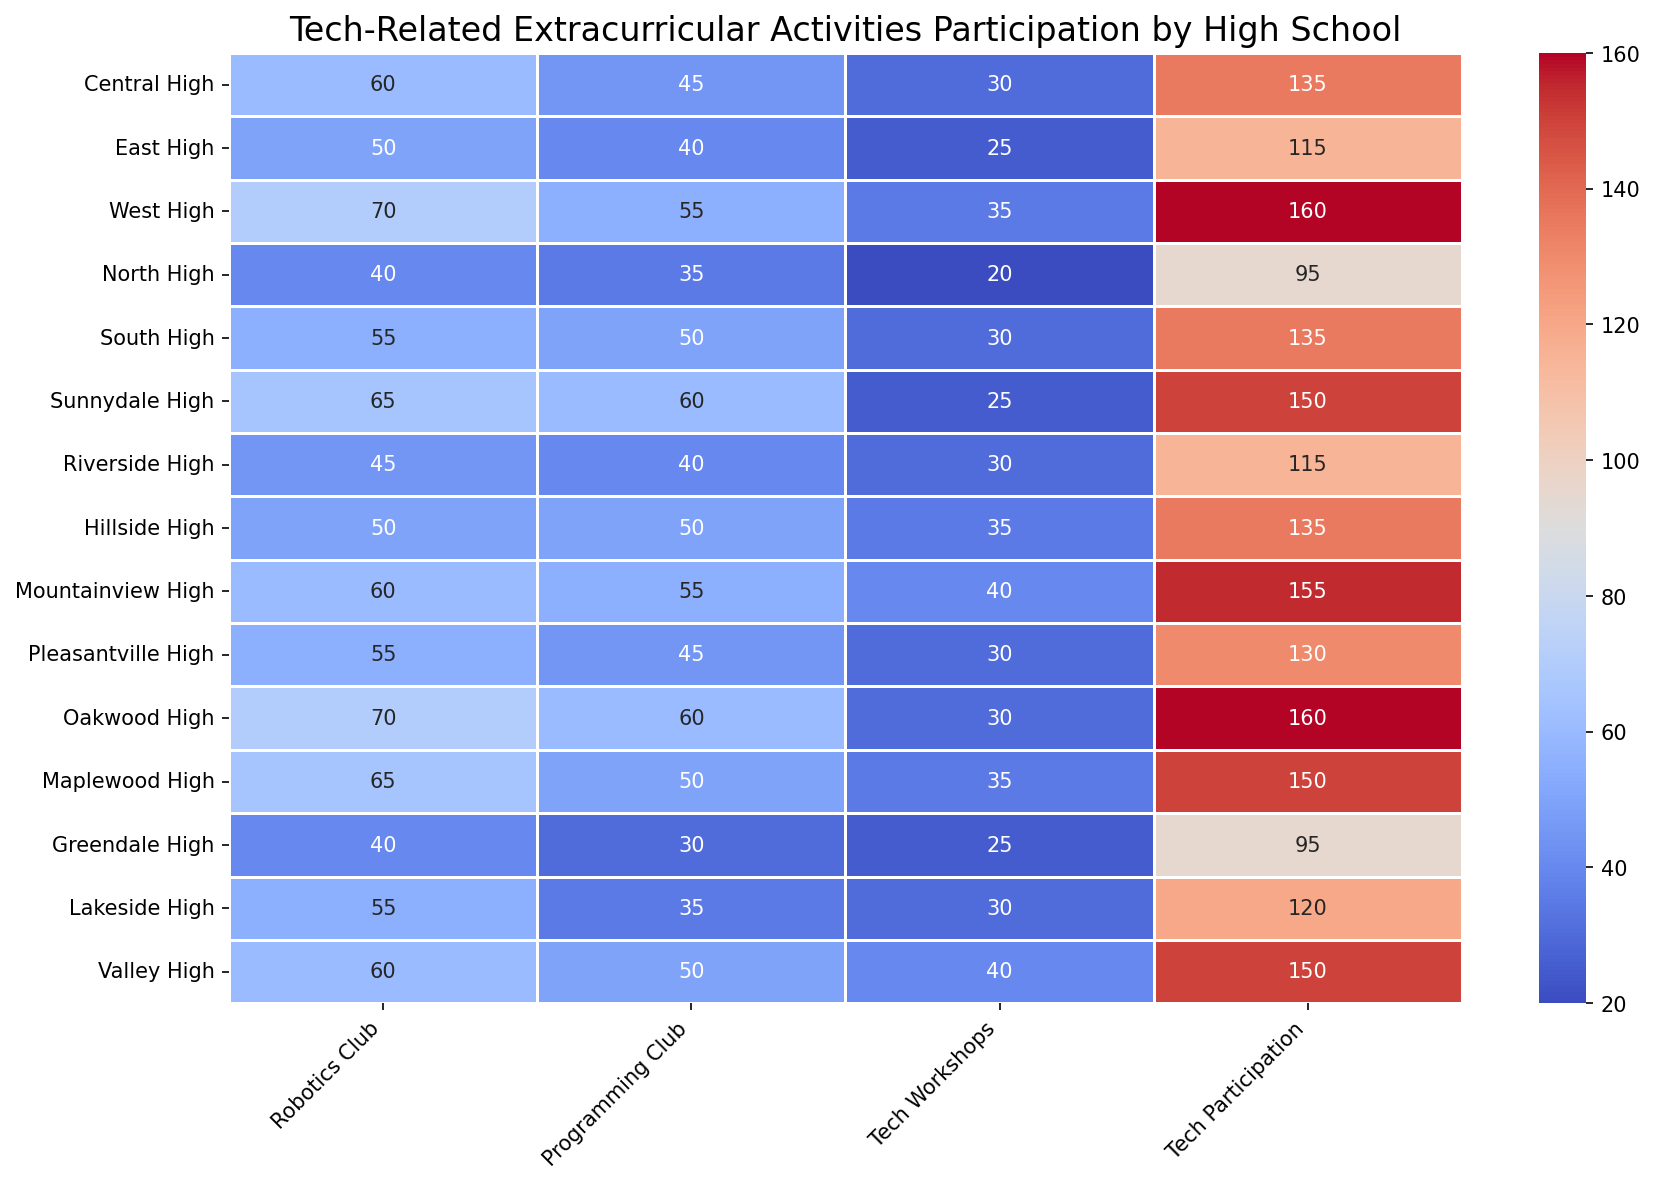Which high school has the highest participation in Tech Workshops? Look at the "Tech Workshops" column and identify the highest number. The school with the highest number is West High with 35 participants.
Answer: West High Which school has the smallest total participation in tech-related activities? To find this, sum the values for Robotics Club, Programming Club, and Tech Workshops for each school and identify the smallest total. Greendale High has the fewest participants with a sum of 95.
Answer: Greendale High What is the difference in tech participation between Sunnydale High and Central High? Find the "Tech Participation" values for both schools and subtract the value for Central High from Sunnydale High (150 - 135).
Answer: 15 Which high school has equal participation in both the Robotics Club and the Programming Club? Look at both the "Robotics Club" and "Programming Club" columns and find a school where the values are the same. Hillside High has 50 participants in both clubs.
Answer: Hillside High What is the average participation in the Robotics Clubs across all high schools? Sum the numbers in the "Robotics Club" column and divide by the number of schools (15). The sum is 835, so the average is 835 / 15 = 55.7.
Answer: 55.7 Which schools have Tech Participation values greater than 150? Identify the schools with "Tech Participation" values more than 150. West High, Mountainview High, Oakwood High, and Valley High have values greater than 150.
Answer: West High, Mountainview High, Oakwood High, Valley High What is the combined participation in Tech Workshops for North High and Riverside High? Add the "Tech Workshops" values for both North High (20) and Riverside High (30), resulting in a total of 50.
Answer: 50 Which high school has the darkest color in the Programming Club column? The darkest color represents the highest value in the heatmap. The highest value in the Programming Club column is 60, and it corresponds to both Sunnydale High and Oakwood High.
Answer: Sunnydale High, Oakwood High What is the total participation for East High across all tech-related activities? Sum the values for East High in the Robotics Club (50), Programming Club (40), Tech Workshops (25), and Tech Participation (115). The total is 230.
Answer: 230 